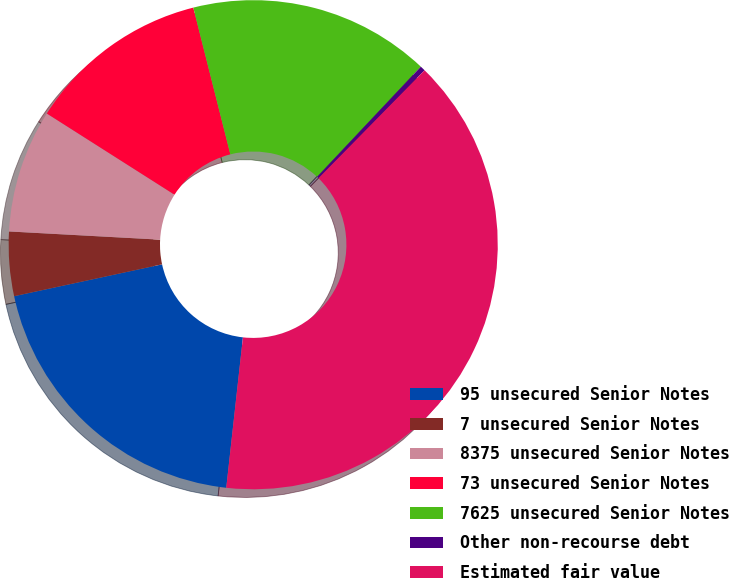Convert chart to OTSL. <chart><loc_0><loc_0><loc_500><loc_500><pie_chart><fcel>95 unsecured Senior Notes<fcel>7 unsecured Senior Notes<fcel>8375 unsecured Senior Notes<fcel>73 unsecured Senior Notes<fcel>7625 unsecured Senior Notes<fcel>Other non-recourse debt<fcel>Estimated fair value<nl><fcel>19.87%<fcel>4.24%<fcel>8.15%<fcel>12.05%<fcel>15.96%<fcel>0.34%<fcel>39.4%<nl></chart> 